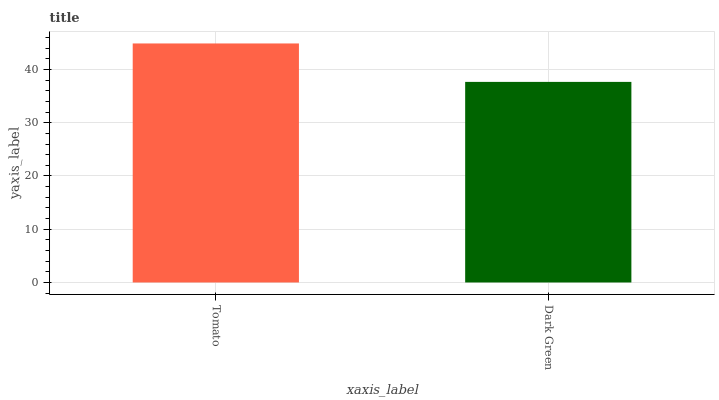Is Dark Green the minimum?
Answer yes or no. Yes. Is Tomato the maximum?
Answer yes or no. Yes. Is Dark Green the maximum?
Answer yes or no. No. Is Tomato greater than Dark Green?
Answer yes or no. Yes. Is Dark Green less than Tomato?
Answer yes or no. Yes. Is Dark Green greater than Tomato?
Answer yes or no. No. Is Tomato less than Dark Green?
Answer yes or no. No. Is Tomato the high median?
Answer yes or no. Yes. Is Dark Green the low median?
Answer yes or no. Yes. Is Dark Green the high median?
Answer yes or no. No. Is Tomato the low median?
Answer yes or no. No. 